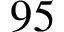Convert formula to latex. <formula><loc_0><loc_0><loc_500><loc_500>9 5</formula> 